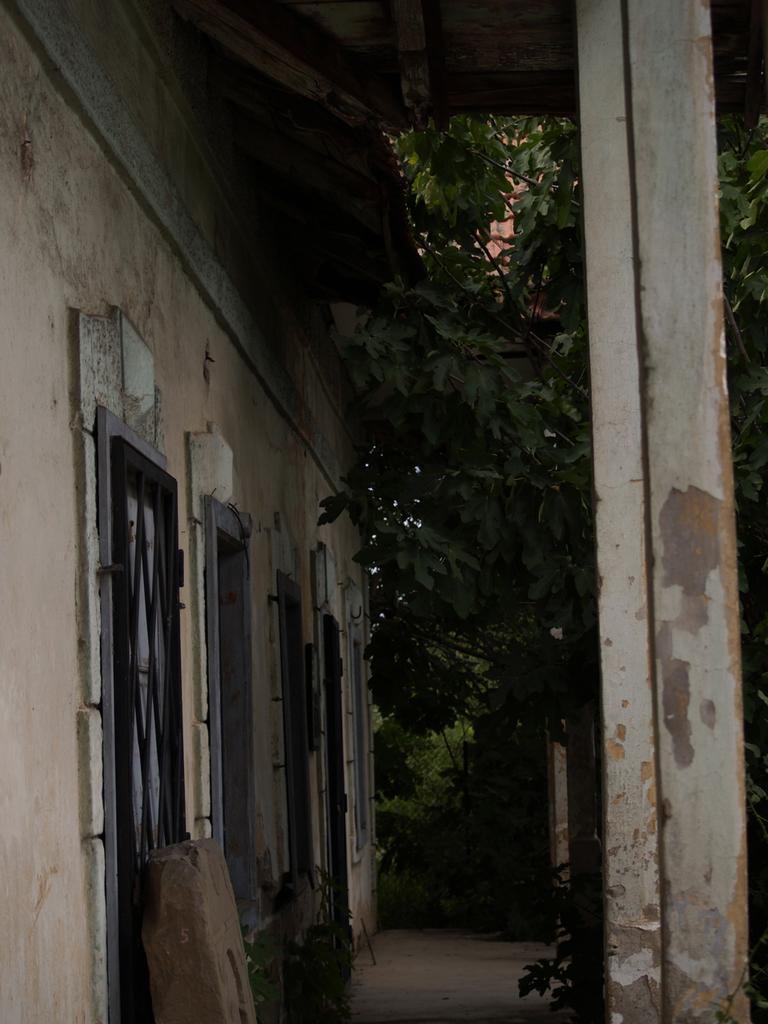Describe this image in one or two sentences. In this image, we can see house, wall, grille, pole, plants, walkway and a few objects. At the top of the image, we can see the ceiling. 